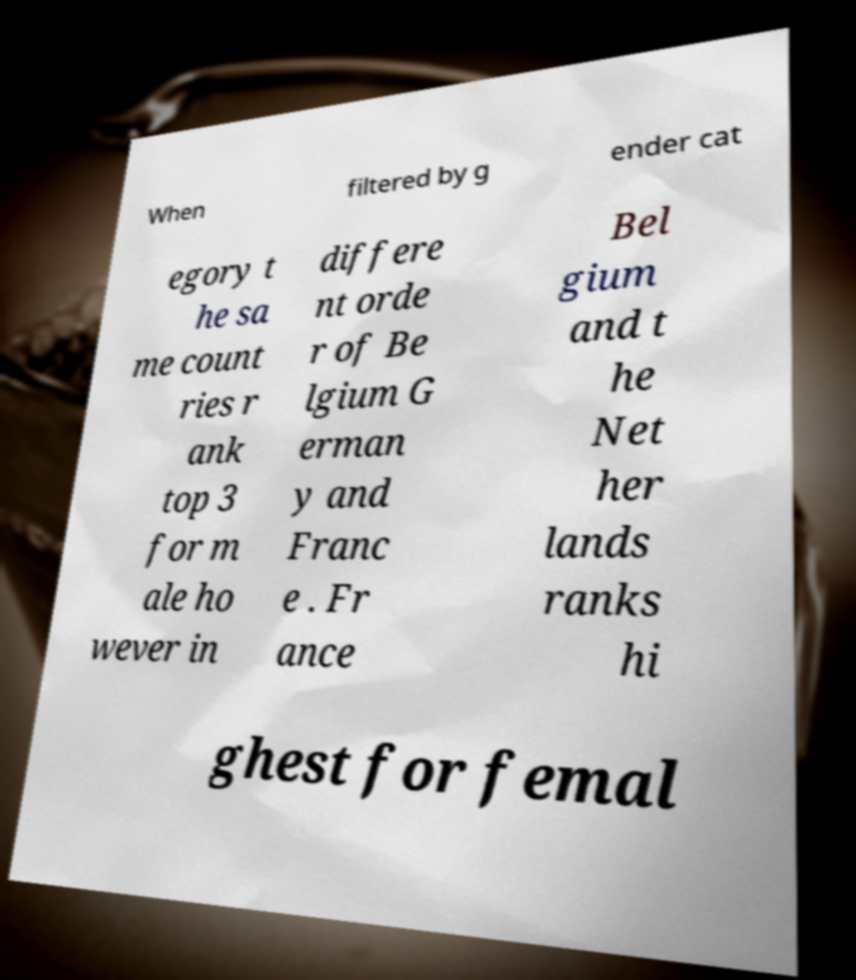Could you extract and type out the text from this image? When filtered by g ender cat egory t he sa me count ries r ank top 3 for m ale ho wever in differe nt orde r of Be lgium G erman y and Franc e . Fr ance Bel gium and t he Net her lands ranks hi ghest for femal 